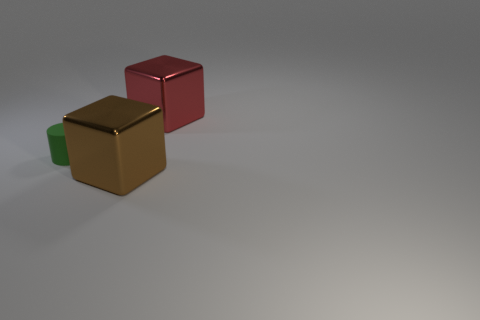Add 1 cylinders. How many objects exist? 4 Subtract 1 blocks. How many blocks are left? 1 Subtract all cylinders. How many objects are left? 2 Add 2 large red objects. How many large red objects exist? 3 Subtract all brown cubes. How many cubes are left? 1 Subtract 0 red spheres. How many objects are left? 3 Subtract all red blocks. Subtract all yellow cylinders. How many blocks are left? 1 Subtract all blue cubes. How many purple cylinders are left? 0 Subtract all green things. Subtract all brown shiny things. How many objects are left? 1 Add 3 brown shiny blocks. How many brown shiny blocks are left? 4 